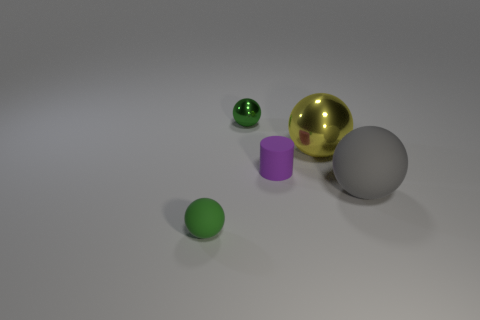Is the size of the green object in front of the purple matte object the same as the yellow sphere?
Your answer should be very brief. No. Does the small shiny sphere have the same color as the tiny rubber sphere?
Offer a very short reply. Yes. What is the material of the other ball that is the same color as the tiny matte ball?
Ensure brevity in your answer.  Metal. Is there any other thing that is the same shape as the small purple rubber thing?
Offer a terse response. No. Is the material of the purple cylinder the same as the small sphere that is in front of the purple rubber cylinder?
Your answer should be compact. Yes. There is a small sphere that is behind the green matte thing to the left of the small green thing behind the rubber cylinder; what is its color?
Give a very brief answer. Green. Does the tiny matte ball have the same color as the tiny ball that is behind the big yellow metal sphere?
Provide a succinct answer. Yes. What is the color of the tiny metallic object?
Your response must be concise. Green. What shape is the object left of the green thing that is behind the small green object that is in front of the tiny metallic ball?
Give a very brief answer. Sphere. What number of other objects are there of the same color as the large rubber ball?
Offer a very short reply. 0. 